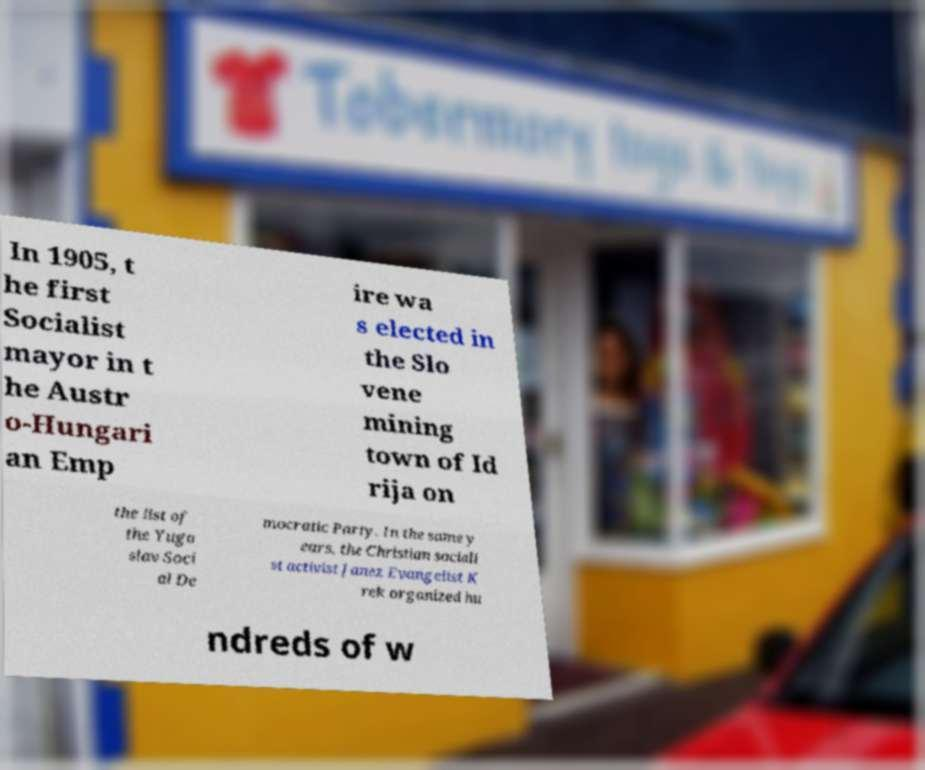Please identify and transcribe the text found in this image. In 1905, t he first Socialist mayor in t he Austr o-Hungari an Emp ire wa s elected in the Slo vene mining town of Id rija on the list of the Yugo slav Soci al De mocratic Party. In the same y ears, the Christian sociali st activist Janez Evangelist K rek organized hu ndreds of w 